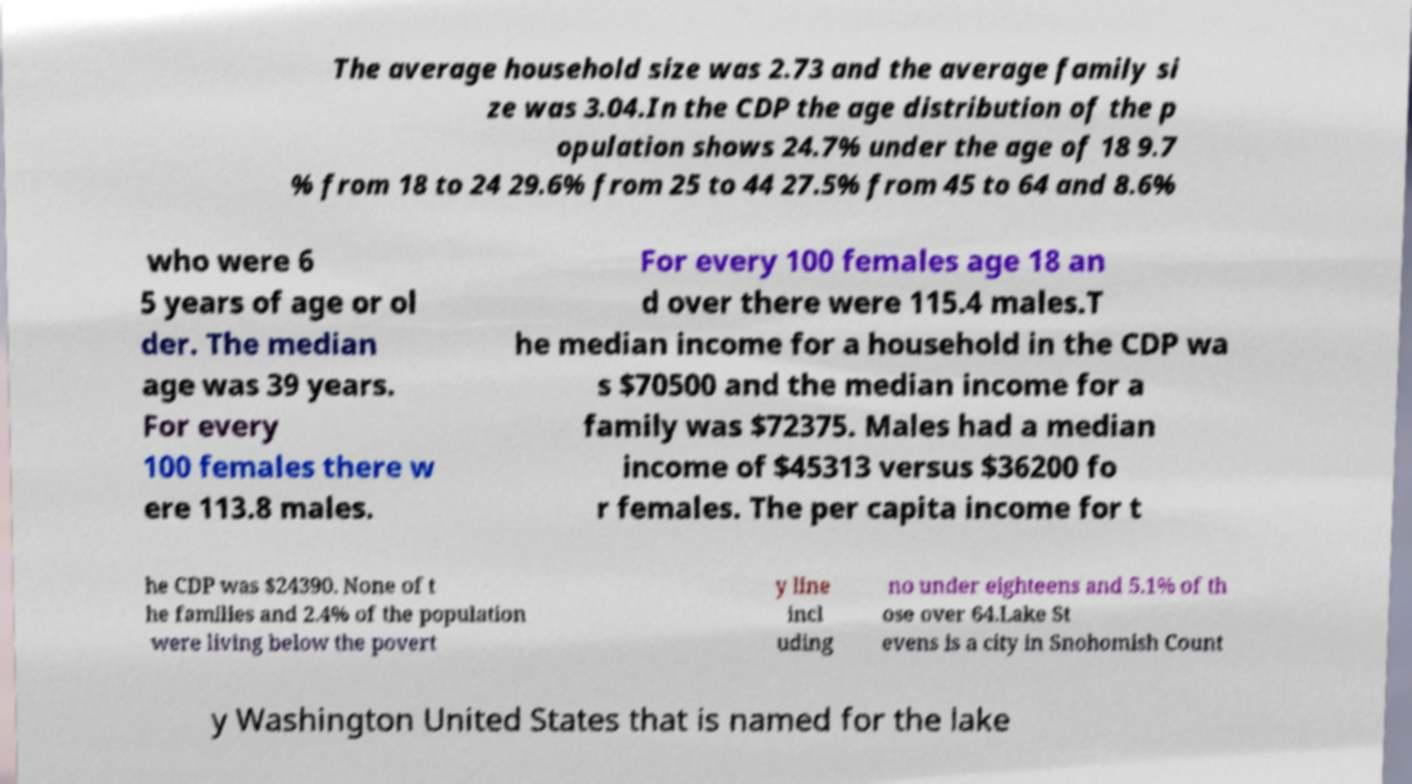Can you read and provide the text displayed in the image?This photo seems to have some interesting text. Can you extract and type it out for me? The average household size was 2.73 and the average family si ze was 3.04.In the CDP the age distribution of the p opulation shows 24.7% under the age of 18 9.7 % from 18 to 24 29.6% from 25 to 44 27.5% from 45 to 64 and 8.6% who were 6 5 years of age or ol der. The median age was 39 years. For every 100 females there w ere 113.8 males. For every 100 females age 18 an d over there were 115.4 males.T he median income for a household in the CDP wa s $70500 and the median income for a family was $72375. Males had a median income of $45313 versus $36200 fo r females. The per capita income for t he CDP was $24390. None of t he families and 2.4% of the population were living below the povert y line incl uding no under eighteens and 5.1% of th ose over 64.Lake St evens is a city in Snohomish Count y Washington United States that is named for the lake 